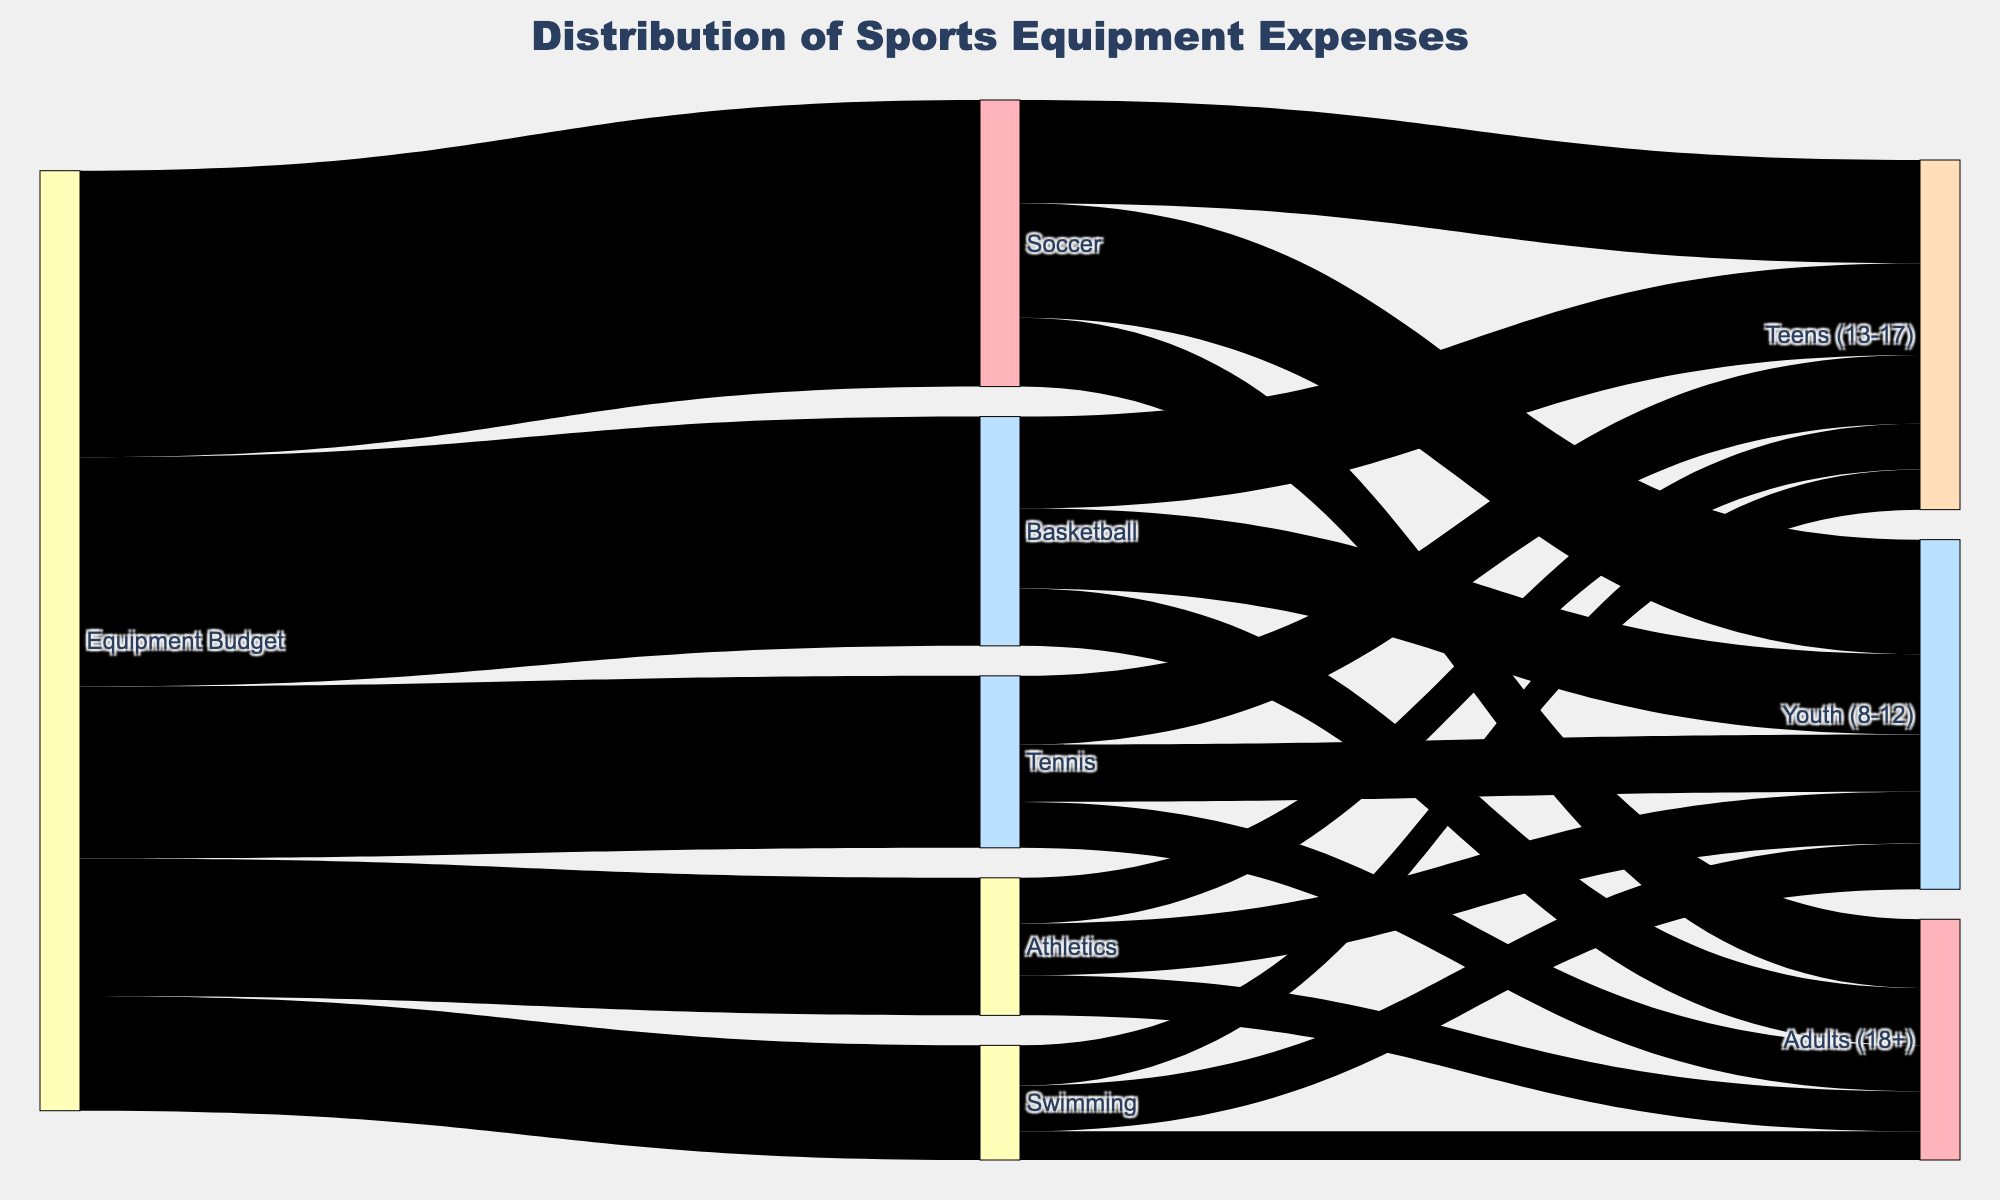How much of the total equipment budget is allocated to Soccer? The figure shows that Soccer receives a budget of 25,000 units. The total equipment budget is depicted as the starting node. Therefore, Soccer receives 25,000 units out of the entire equipment budget.
Answer: 25,000 units What sport receives the least amount of funding from the equipment budget? Observe the initial branches from the "Equipment Budget" node to determine the values allocated to each sport. Swimming receives the least funding, with a value of 10,000 units.
Answer: Swimming Which age group in Soccer gets the most funding? Look at the branches stemming from the "Soccer" node to each age group. The "Youth (8-12)" age group receives the most funding, with a value of 10,000 units.
Answer: Youth (8-12) How much funding is allocated to Tennis for the Teens (13-17) age group? Follow the branch from the "Tennis" node to the "Teens (13-17)" node, which shows the value of 6,000 units.
Answer: 6,000 units Comparing Basketball and Athletics, which sport allocates more money to the Adults (18+) age group? Look at the branches from both "Basketball" and "Athletics" nodes to the "Adults (18+)" age group. Basketball allocates 5,000 units while Athletics allocates 3,500 units. Therefore, Basketball allocates more.
Answer: Basketball What is the total funding allocated to the Teens (13-17) age group for all sports combined? Add the values from the "Teens (13-17)" nodes for Soccer (9,000 units), Basketball (8,000 units), Tennis (6,000 units), Swimming (3,500 units), and Athletics (4,000 units). The total is 30,500 units.
Answer: 30,500 units Which age group in Swimming receives the least amount of funding? Look at the branches stemming from the "Swimming" node. The "Adults (18+)" age group receives the least funding, with a value of 2,500 units.
Answer: Adults (18+) What is the difference in funding between the Youth (8-12) age group and the Adults (18+) age group for Athletics? Check the branches from the "Athletics" node for both age groups. Youth (8-12) has 4,500 units and Adults (18+) has 3,500 units. The difference is 4,500 - 3,500 = 1,000 units.
Answer: 1,000 units How many different age groups are represented in the figure? Count the unique age groups linked from various sports. They are "Youth (8-12)", "Teens (13-17)", and "Adults (18+)". There are 3 different age groups.
Answer: 3 In the sport of Soccer, what is the proportion of funding allocated to the Youth (8-12) age group compared to the total funding for Soccer? Soccer has a total funding of 25,000 units. The Youth (8-12) age group gets 10,000 units. The proportion is (10,000 / 25,000) = 0.4 or 40%.
Answer: 40% 